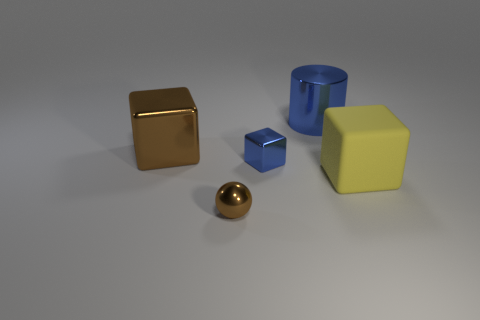What is the shape of the brown object that is the same material as the brown cube?
Ensure brevity in your answer.  Sphere. What number of other objects are the same shape as the big blue object?
Provide a short and direct response. 0. Are there any other things that have the same color as the shiny sphere?
Your response must be concise. Yes. How many small things are balls or brown cylinders?
Ensure brevity in your answer.  1. There is a brown shiny thing that is in front of the block in front of the small block that is behind the big yellow matte block; what size is it?
Give a very brief answer. Small. How many other blocks have the same size as the brown block?
Keep it short and to the point. 1. How many objects are either metallic blocks or big cubes in front of the large brown shiny thing?
Your response must be concise. 3. The large blue object is what shape?
Provide a short and direct response. Cylinder. Is the large rubber block the same color as the tiny metallic cube?
Make the answer very short. No. What color is the object that is the same size as the ball?
Make the answer very short. Blue. 